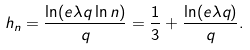<formula> <loc_0><loc_0><loc_500><loc_500>h _ { n } = \frac { \ln ( e \lambda q \ln n ) } { q } = \frac { 1 } { 3 } + \frac { \ln ( e \lambda q ) } { q } .</formula> 